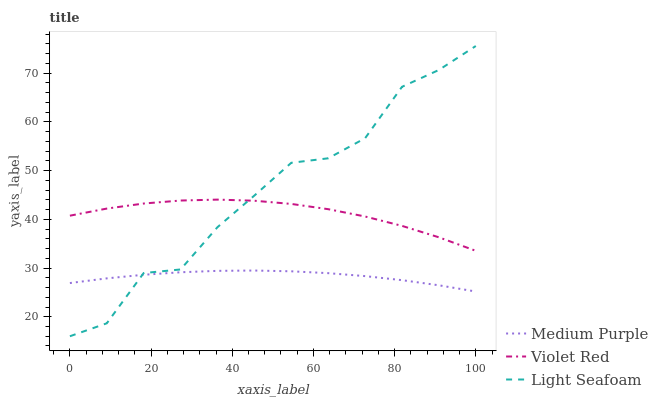Does Medium Purple have the minimum area under the curve?
Answer yes or no. Yes. Does Light Seafoam have the maximum area under the curve?
Answer yes or no. Yes. Does Violet Red have the minimum area under the curve?
Answer yes or no. No. Does Violet Red have the maximum area under the curve?
Answer yes or no. No. Is Medium Purple the smoothest?
Answer yes or no. Yes. Is Light Seafoam the roughest?
Answer yes or no. Yes. Is Violet Red the smoothest?
Answer yes or no. No. Is Violet Red the roughest?
Answer yes or no. No. Does Light Seafoam have the lowest value?
Answer yes or no. Yes. Does Violet Red have the lowest value?
Answer yes or no. No. Does Light Seafoam have the highest value?
Answer yes or no. Yes. Does Violet Red have the highest value?
Answer yes or no. No. Is Medium Purple less than Violet Red?
Answer yes or no. Yes. Is Violet Red greater than Medium Purple?
Answer yes or no. Yes. Does Violet Red intersect Light Seafoam?
Answer yes or no. Yes. Is Violet Red less than Light Seafoam?
Answer yes or no. No. Is Violet Red greater than Light Seafoam?
Answer yes or no. No. Does Medium Purple intersect Violet Red?
Answer yes or no. No. 